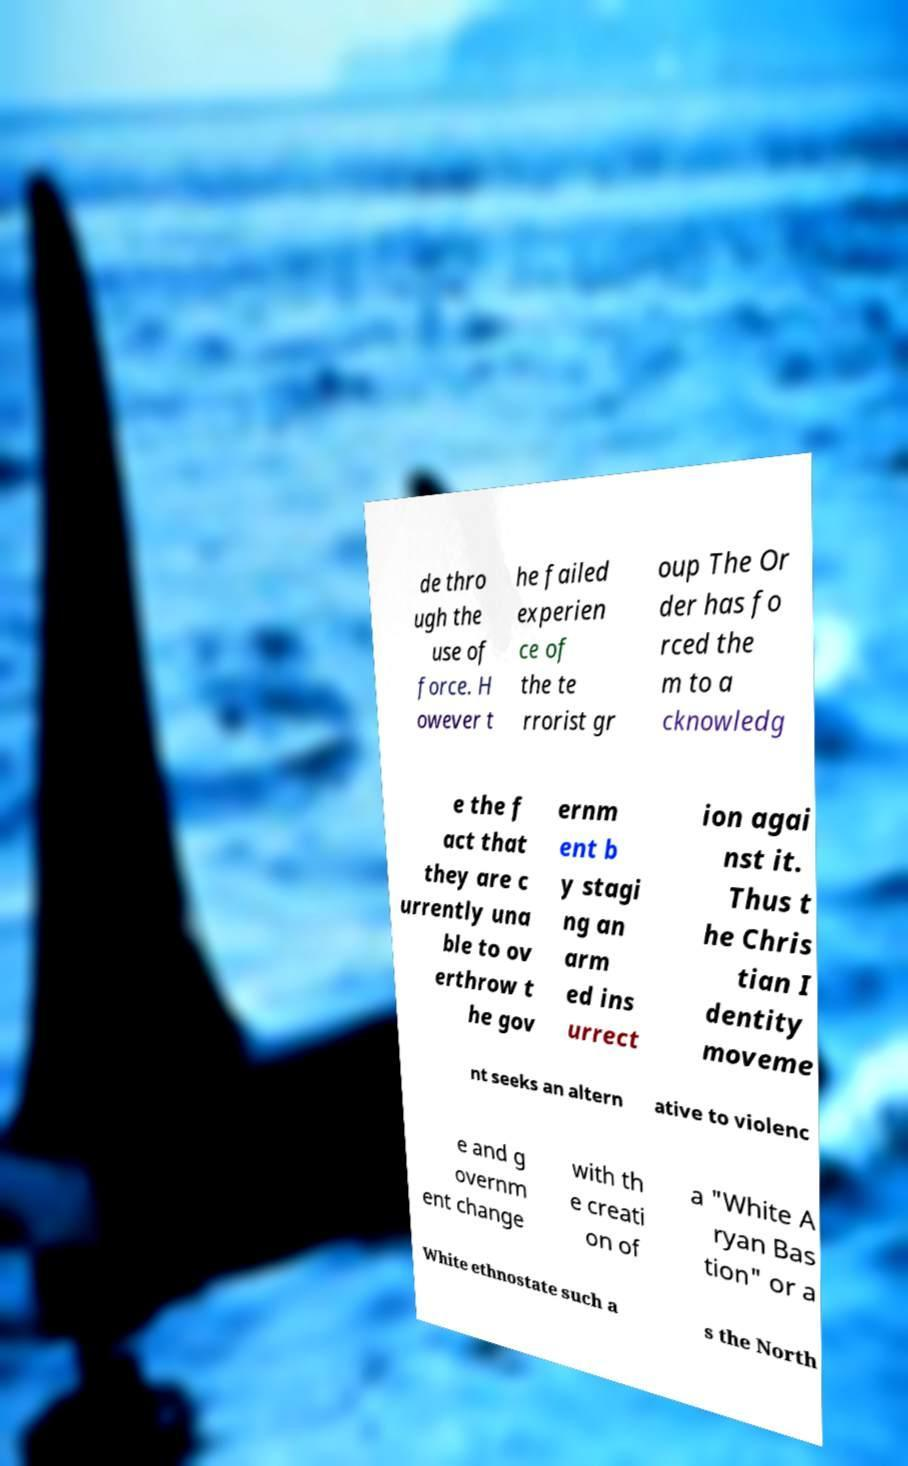Please read and relay the text visible in this image. What does it say? de thro ugh the use of force. H owever t he failed experien ce of the te rrorist gr oup The Or der has fo rced the m to a cknowledg e the f act that they are c urrently una ble to ov erthrow t he gov ernm ent b y stagi ng an arm ed ins urrect ion agai nst it. Thus t he Chris tian I dentity moveme nt seeks an altern ative to violenc e and g overnm ent change with th e creati on of a "White A ryan Bas tion" or a White ethnostate such a s the North 